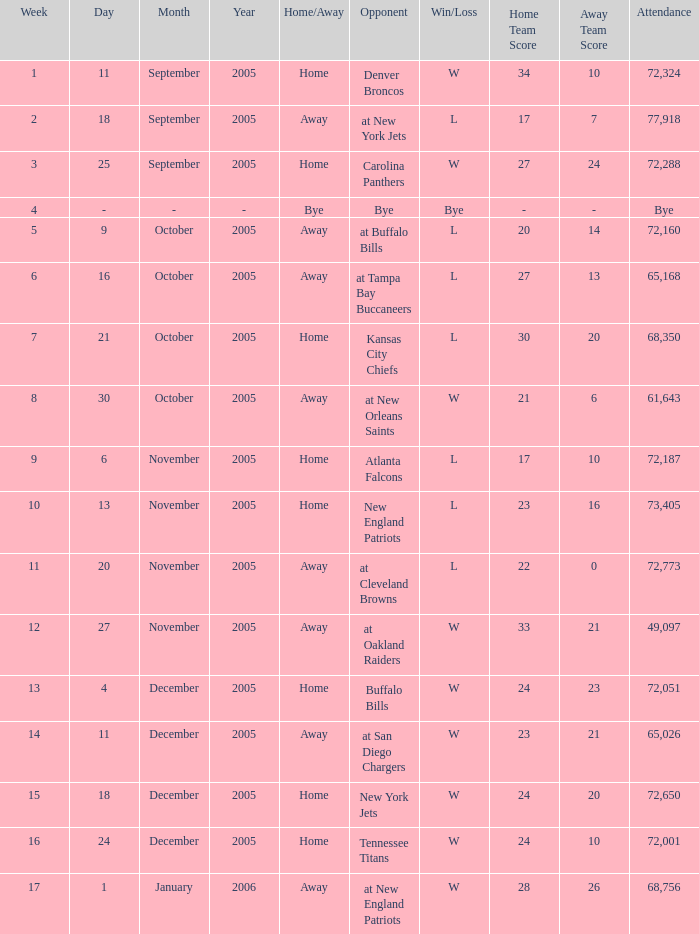What is the Week with a Date of Bye? 1.0. 